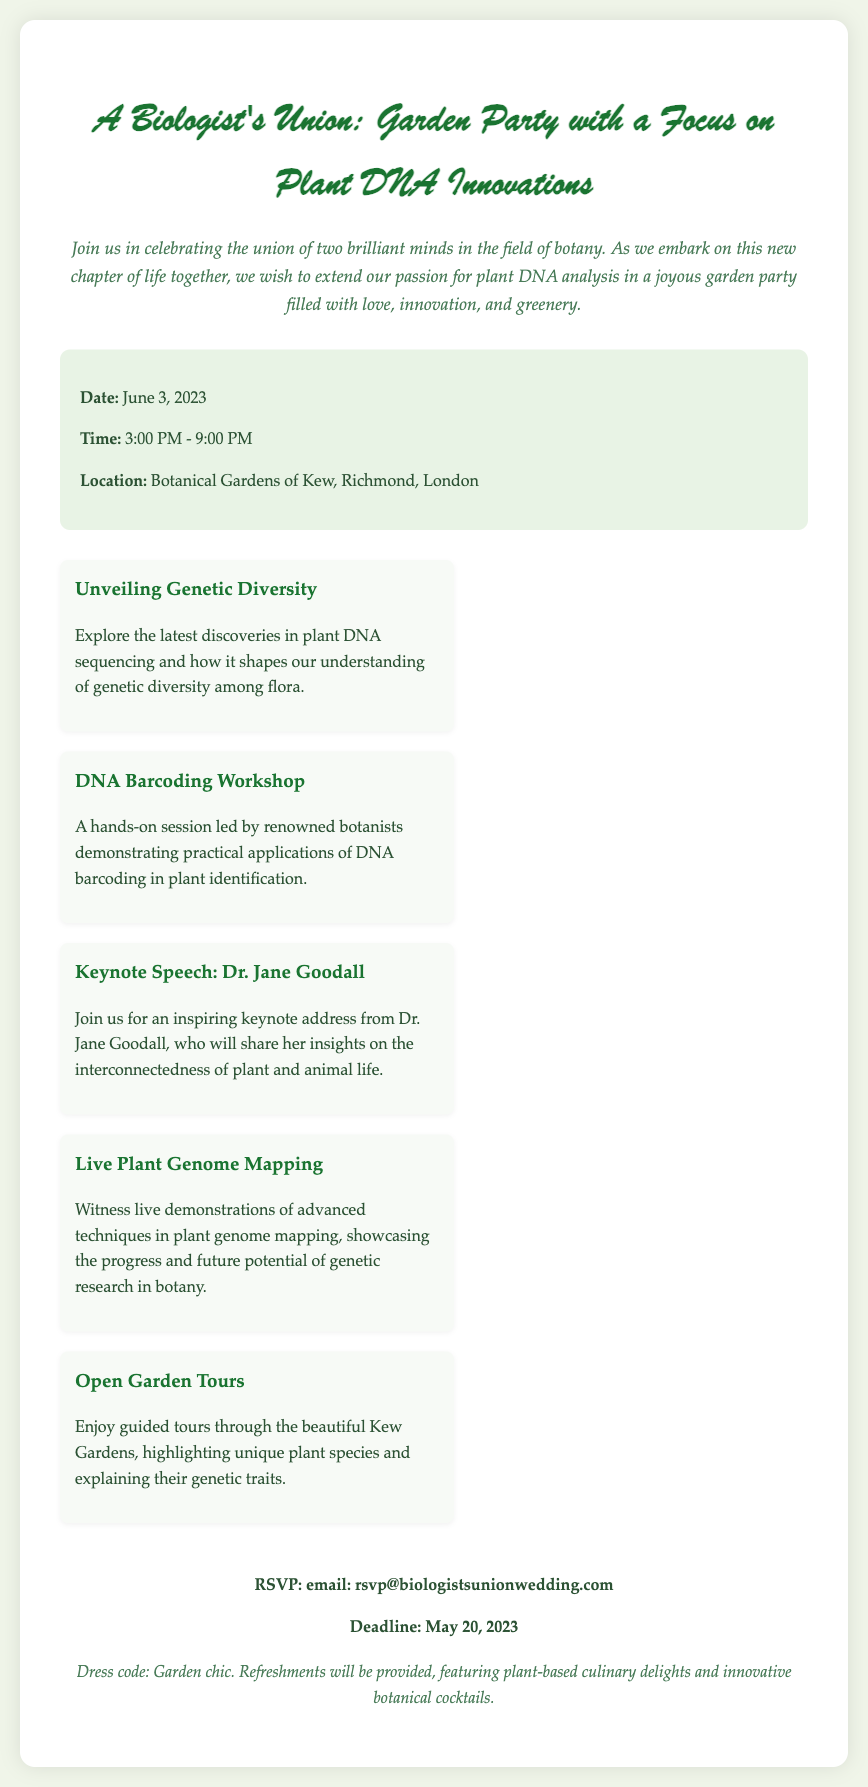What is the date of the event? The date of the event is clearly stated in the document under event details.
Answer: June 3, 2023 What time does the garden party start? The time of the event is mentioned specifically in the document.
Answer: 3:00 PM Where is the garden party being held? The location is specified in the event details section of the document.
Answer: Botanical Gardens of Kew, Richmond, London Who is giving the keynote speech? The document lists the keynote speaker in the highlights section.
Answer: Dr. Jane Goodall What is one of the activities offered during the event? The document describes activities in the highlights section and multiple options are provided.
Answer: DNA Barcoding Workshop What is the RSVP deadline? The RSVP information is provided towards the end of the document.
Answer: May 20, 2023 What is the dress code for the event? The dress code is mentioned in the additional info section of the document.
Answer: Garden chic How many highlight items are listed? The document includes several highlight items showcased in a specific section and can be counted.
Answer: Five 